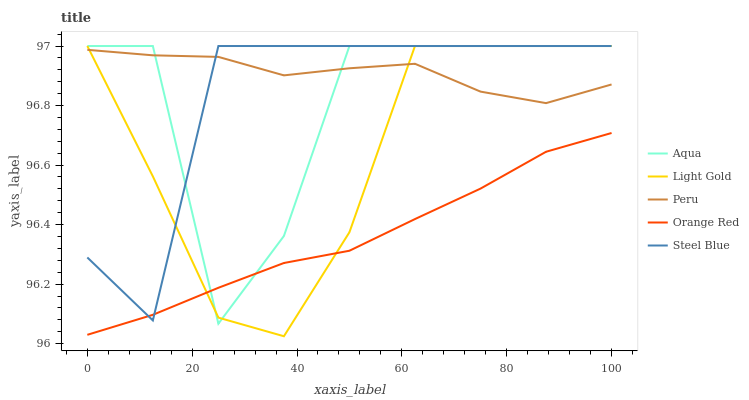Does Orange Red have the minimum area under the curve?
Answer yes or no. Yes. Does Peru have the maximum area under the curve?
Answer yes or no. Yes. Does Aqua have the minimum area under the curve?
Answer yes or no. No. Does Aqua have the maximum area under the curve?
Answer yes or no. No. Is Orange Red the smoothest?
Answer yes or no. Yes. Is Aqua the roughest?
Answer yes or no. Yes. Is Aqua the smoothest?
Answer yes or no. No. Is Orange Red the roughest?
Answer yes or no. No. Does Light Gold have the lowest value?
Answer yes or no. Yes. Does Aqua have the lowest value?
Answer yes or no. No. Does Steel Blue have the highest value?
Answer yes or no. Yes. Does Orange Red have the highest value?
Answer yes or no. No. Is Orange Red less than Peru?
Answer yes or no. Yes. Is Peru greater than Orange Red?
Answer yes or no. Yes. Does Aqua intersect Peru?
Answer yes or no. Yes. Is Aqua less than Peru?
Answer yes or no. No. Is Aqua greater than Peru?
Answer yes or no. No. Does Orange Red intersect Peru?
Answer yes or no. No. 